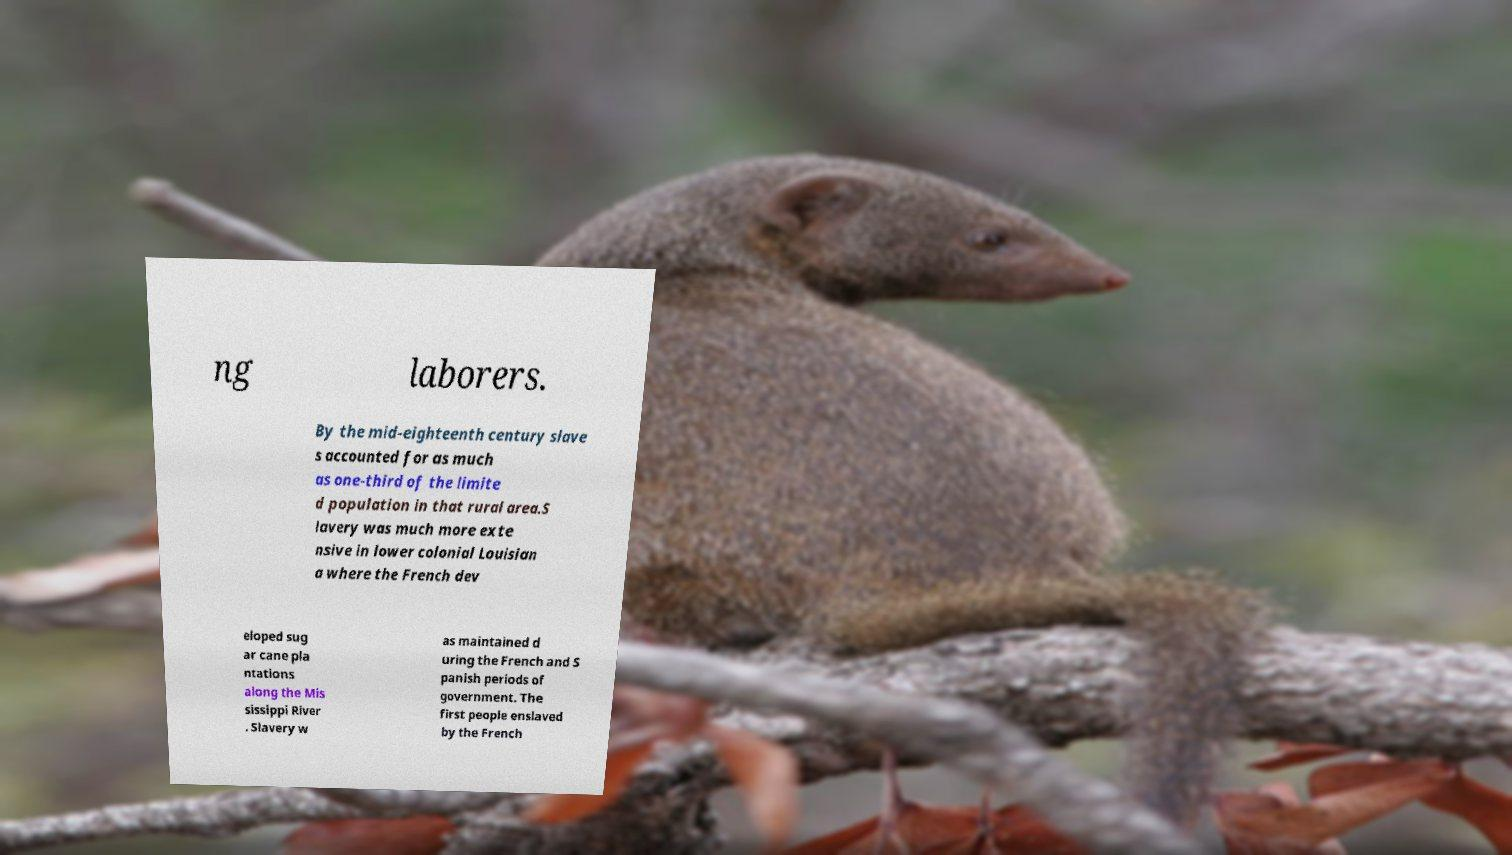I need the written content from this picture converted into text. Can you do that? ng laborers. By the mid-eighteenth century slave s accounted for as much as one-third of the limite d population in that rural area.S lavery was much more exte nsive in lower colonial Louisian a where the French dev eloped sug ar cane pla ntations along the Mis sissippi River . Slavery w as maintained d uring the French and S panish periods of government. The first people enslaved by the French 